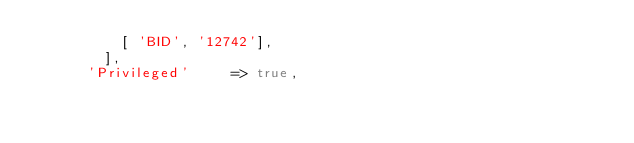Convert code to text. <code><loc_0><loc_0><loc_500><loc_500><_Ruby_>          [ 'BID', '12742'],
        ],
      'Privileged'     => true,</code> 